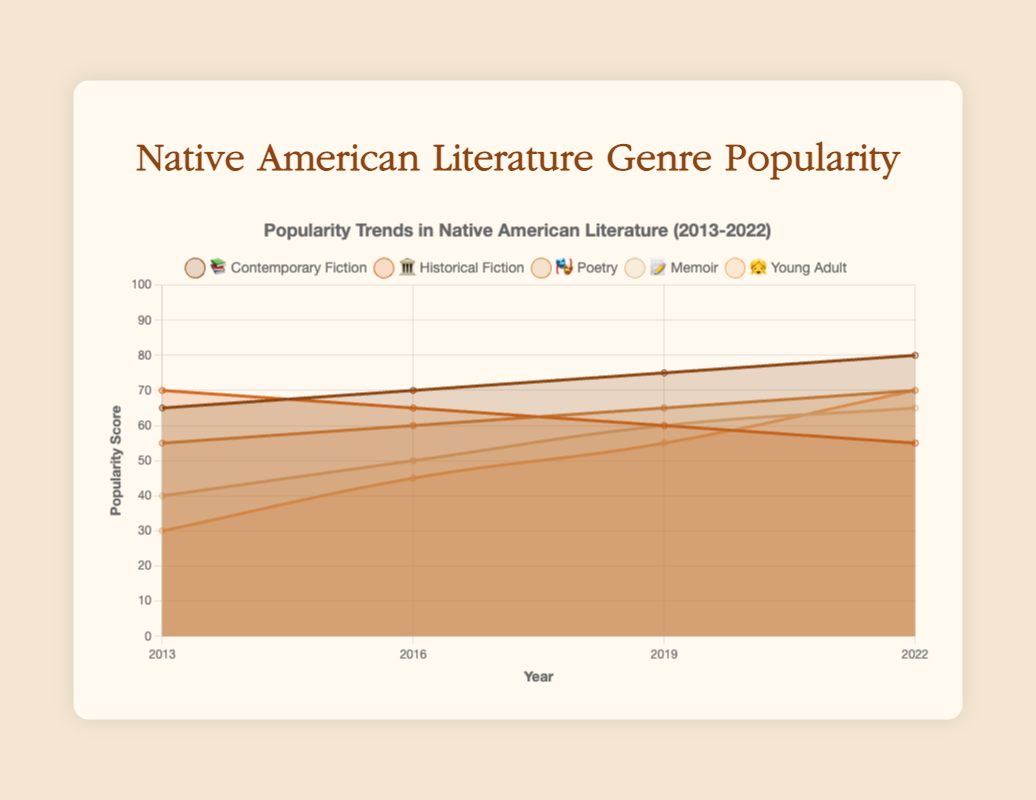What's the title of the figure? The title of the figure is shown at the top, which summarizes the visual's main theme.
Answer: Popularity Trends in Native American Literature (2013-2022) Which genre had the highest popularity score in 2022? By looking at the last data point for each genre in the year 2022, we can see which line reaches the highest point on the y-axis.
Answer: Young Adult What trend do you observe in the popularity of Memoir (📝) over the years? By tracking the Memoir (📝) line from 2013 to 2022, we observe an increasing slope. Specifically, it starts at 40 in 2013 and rises to 65 by 2022.
Answer: Increasing trend Which genre showed a continuous increase in its popularity score from 2013 to 2022? By examining the trend lines for each genre, only Contemporary Fiction (📚) shows a steady increase: 65 in 2013, 70 in 2016, 75 in 2019, and 80 in 2022.
Answer: Contemporary Fiction How much did Historical Fiction (🏛️) decline from 2013 to 2022? The popularity score for Historical Fiction (🏛️) was 70 in 2013 and decreased to 55 in 2022. The decline is calculated as 70 - 55.
Answer: 15 points In which year did Poetry (🎭) see the sharpest increase in its popularity score? By comparing the changes in Poetry's (🎭) score over the years, we find the differences: 2013-2016 (55 to 60 = +5), 2016-2019 (60 to 65 = +5), and 2019-2022 (65 to 70 = +5). The sharpest increase happens between 2013 and 2016, 2016 and 2019, and 2019 and 2022, all showing the same increment.
Answer: 2013-2016, 2016-2019, and 2019-2022 If we average the popularity scores of Young Adult (👧) across all years shown, what value do we get? The scores for Young Adult (👧) are 30 (2013), 45 (2016), 55 (2019), and 70 (2022). The average is calculated by summing these values and dividing by the number of years: (30 + 45 + 55 + 70) / 4.
Answer: 50 Among Contemporary Fiction (📚) and Poetry (🎭), which had higher scores in 2019? Comparing the values in 2019 for Contemporary Fiction (📚) and Poetry (🎭), we see they are 75 and 65, respectively. Contemporary Fiction has a higher score.
Answer: Contemporary Fiction What is the difference in the popularity score between Poetry (🎭) and Historical Fiction (🏛️) in 2022? In 2022, Poetry (🎭) has a score of 70 and Historical Fiction (🏛️) has 55. The difference is calculated by subtracting Historical Fiction's score from Poetry's.
Answer: 15 points 